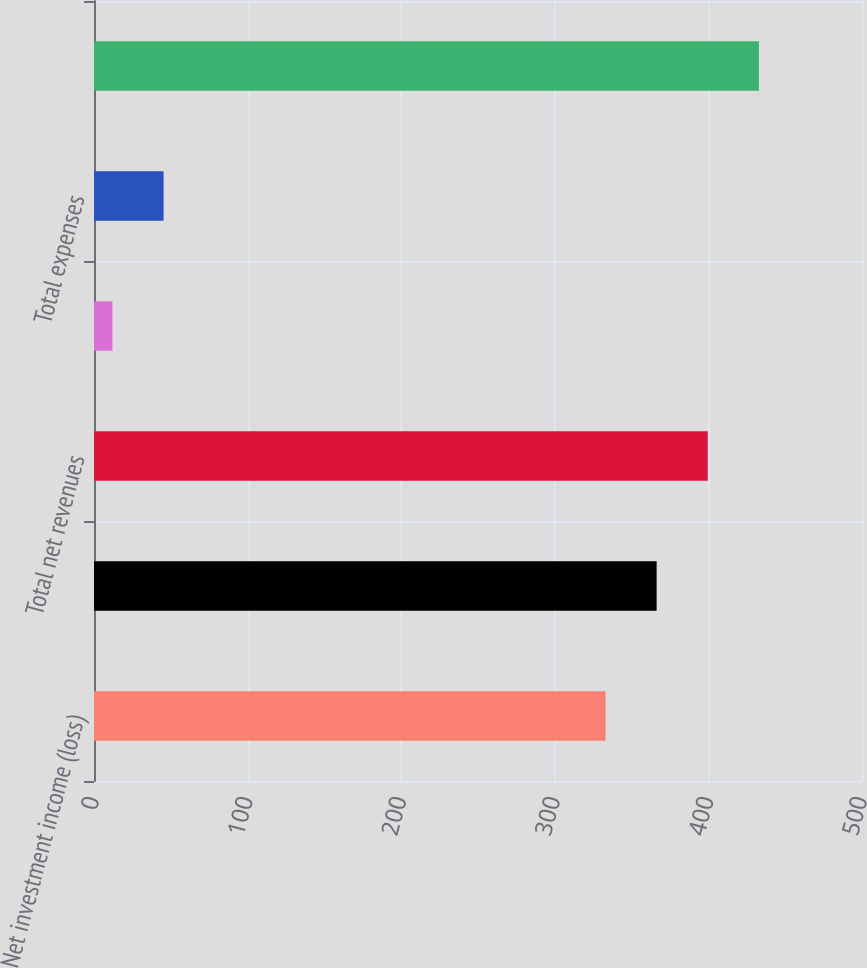Convert chart. <chart><loc_0><loc_0><loc_500><loc_500><bar_chart><fcel>Net investment income (loss)<fcel>Total revenues<fcel>Total net revenues<fcel>General and administrative<fcel>Total expenses<fcel>Pretax income (loss)<nl><fcel>333<fcel>366.3<fcel>399.6<fcel>12<fcel>45.3<fcel>432.9<nl></chart> 